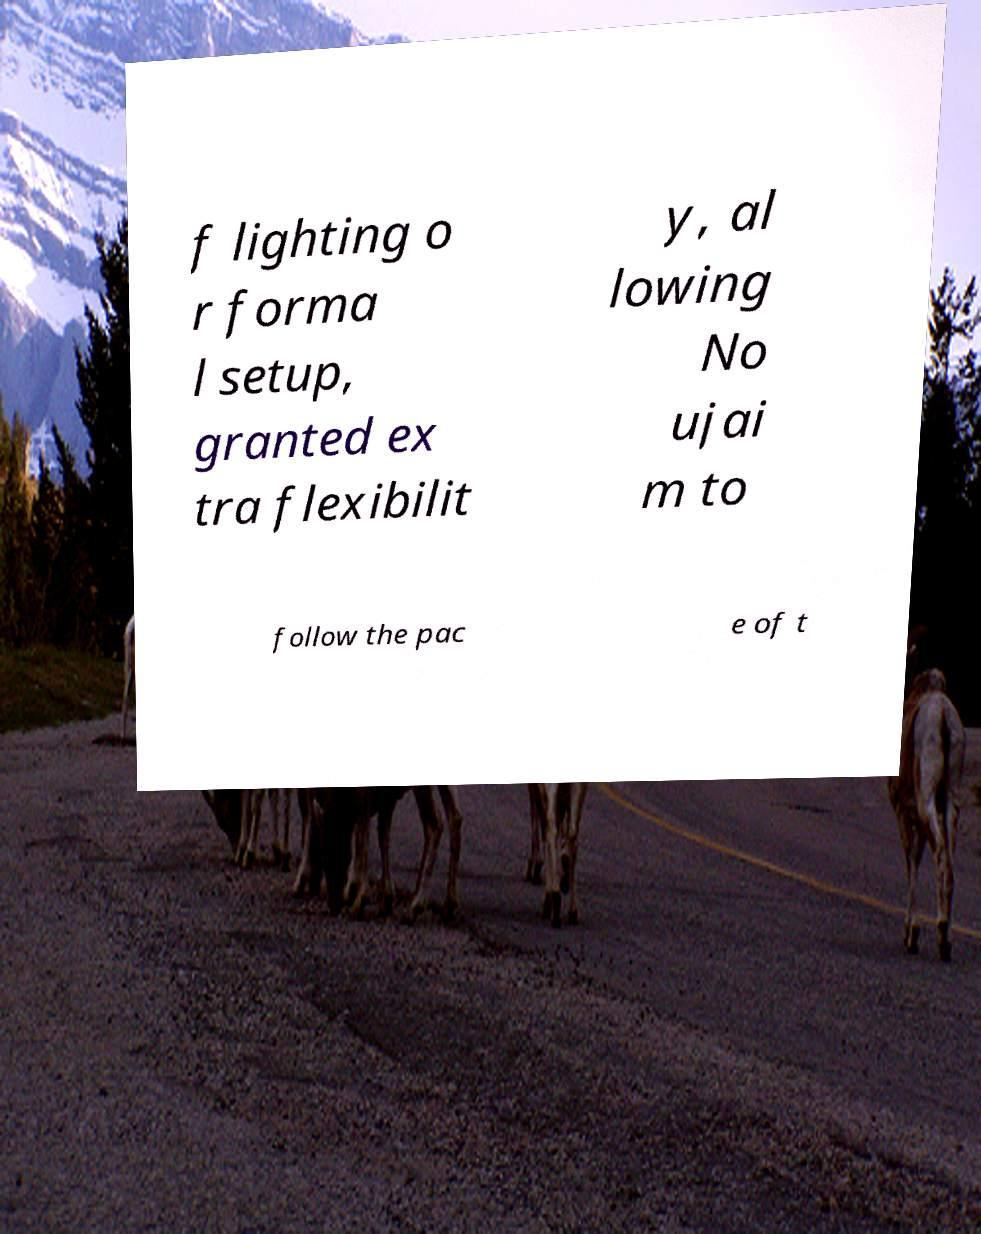Please read and relay the text visible in this image. What does it say? f lighting o r forma l setup, granted ex tra flexibilit y, al lowing No ujai m to follow the pac e of t 